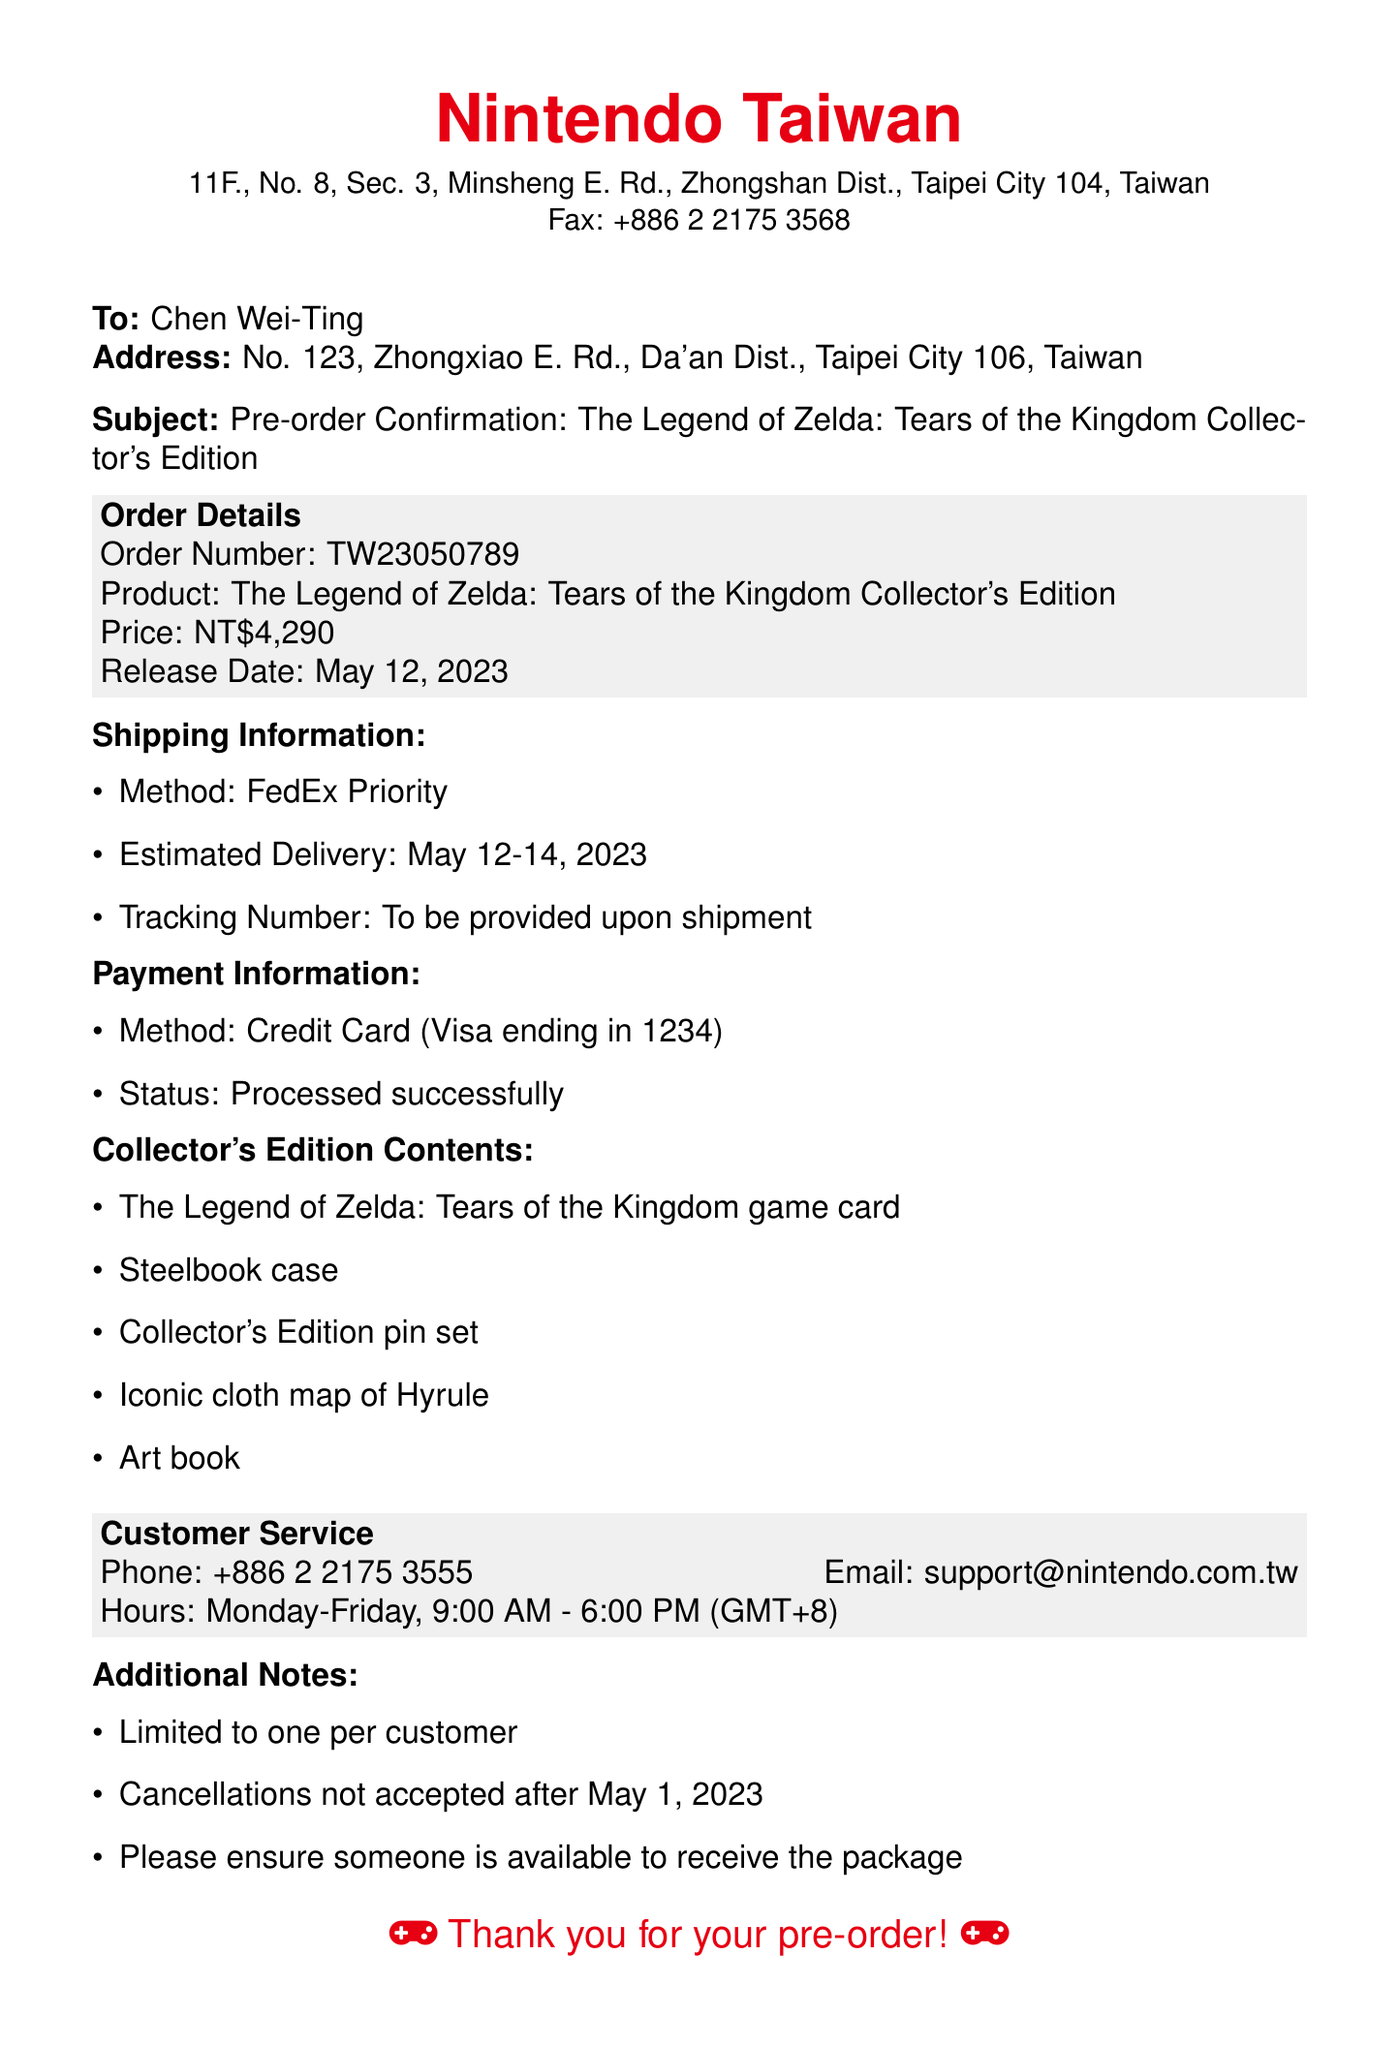What is the order number? The order number is provided in the order details section of the document.
Answer: TW23050789 What is the price of the Collector's Edition? The price is specified in the order details section.
Answer: NT$4,290 When is the estimated delivery date? The estimated delivery date can be found in the shipping information section.
Answer: May 12-14, 2023 What method is used for shipping? The shipping method is listed in the shipping information section.
Answer: FedEx Priority What contents are included in the Collector's Edition? The contents are detailed in the section about the Collector's Edition contents.
Answer: Game card, Steelbook case, Collector's Edition pin set, Cloth map, Art book Who should I contact for customer service? Customer service contact details are provided at the end of the document.
Answer: +886 2 2175 3555 How many items can be ordered per customer? The document states limitations on ordering in the additional notes section.
Answer: One What is the status of the payment? The payment status is mentioned in the payment information section of the document.
Answer: Processed successfully What is the email address for customer support? The email address is included in the customer service section of the document.
Answer: support@nintendo.com.tw 